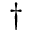<formula> <loc_0><loc_0><loc_500><loc_500>^ { \dagger }</formula> 